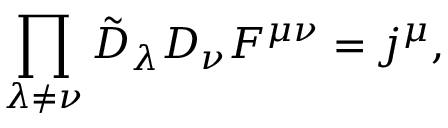Convert formula to latex. <formula><loc_0><loc_0><loc_500><loc_500>\prod _ { \lambda \ne \nu } \tilde { D } _ { \lambda } D _ { \nu } F ^ { \mu \nu } = j ^ { \mu } ,</formula> 